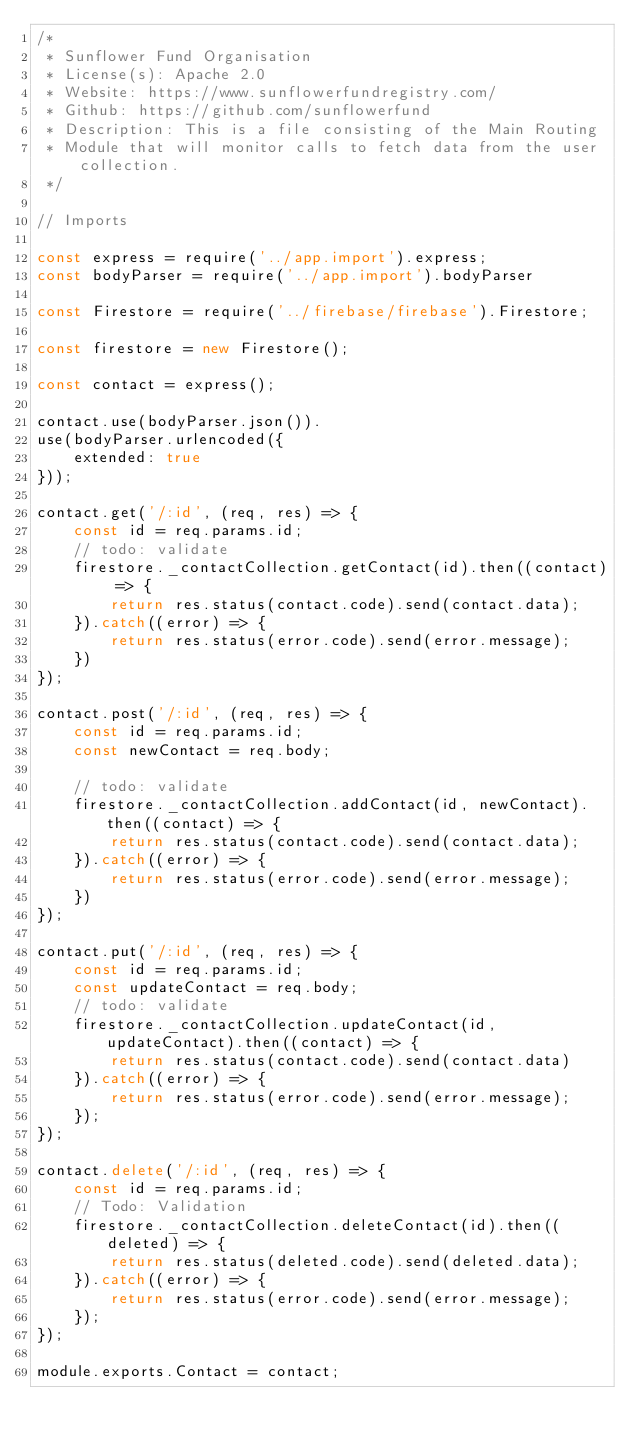<code> <loc_0><loc_0><loc_500><loc_500><_JavaScript_>/*
 * Sunflower Fund Organisation
 * License(s): Apache 2.0
 * Website: https://www.sunflowerfundregistry.com/
 * Github: https://github.com/sunflowerfund
 * Description: This is a file consisting of the Main Routing
 * Module that will monitor calls to fetch data from the user collection.
 */

// Imports

const express = require('../app.import').express;
const bodyParser = require('../app.import').bodyParser

const Firestore = require('../firebase/firebase').Firestore;

const firestore = new Firestore();

const contact = express();

contact.use(bodyParser.json()).
use(bodyParser.urlencoded({
    extended: true
}));

contact.get('/:id', (req, res) => {
    const id = req.params.id;
    // todo: validate
    firestore._contactCollection.getContact(id).then((contact) => {
        return res.status(contact.code).send(contact.data);
    }).catch((error) => {
        return res.status(error.code).send(error.message);
    })
});

contact.post('/:id', (req, res) => {
    const id = req.params.id;
    const newContact = req.body;

    // todo: validate
    firestore._contactCollection.addContact(id, newContact).then((contact) => {
        return res.status(contact.code).send(contact.data);
    }).catch((error) => {
        return res.status(error.code).send(error.message);
    })
});

contact.put('/:id', (req, res) => {
    const id = req.params.id;
    const updateContact = req.body;
    // todo: validate
    firestore._contactCollection.updateContact(id, updateContact).then((contact) => {
        return res.status(contact.code).send(contact.data)
    }).catch((error) => {
        return res.status(error.code).send(error.message);
    });
});

contact.delete('/:id', (req, res) => {
    const id = req.params.id;
    // Todo: Validation
    firestore._contactCollection.deleteContact(id).then((deleted) => {
        return res.status(deleted.code).send(deleted.data);
    }).catch((error) => {
        return res.status(error.code).send(error.message);
    });
});

module.exports.Contact = contact;</code> 